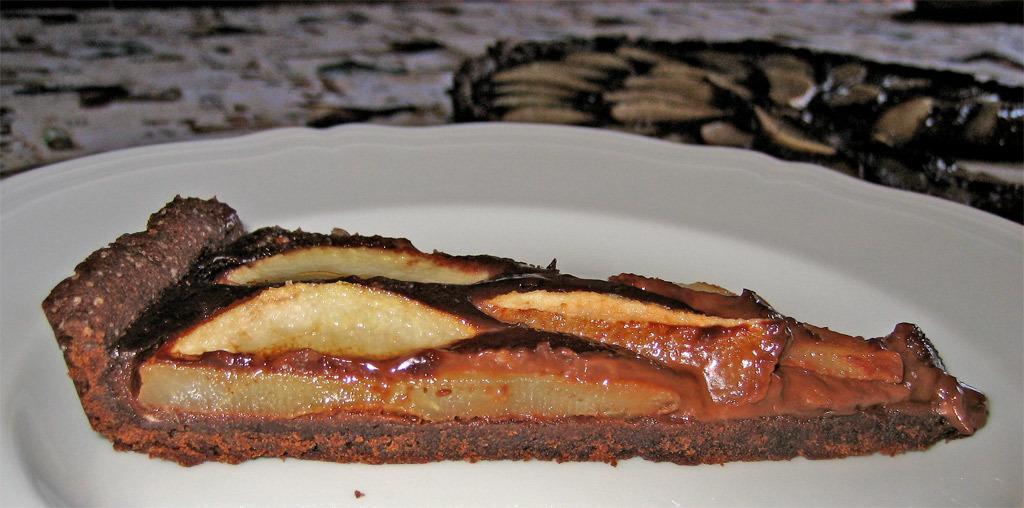Please provide a concise description of this image. In this picture we can see food in the plate and we can see blurry background. 